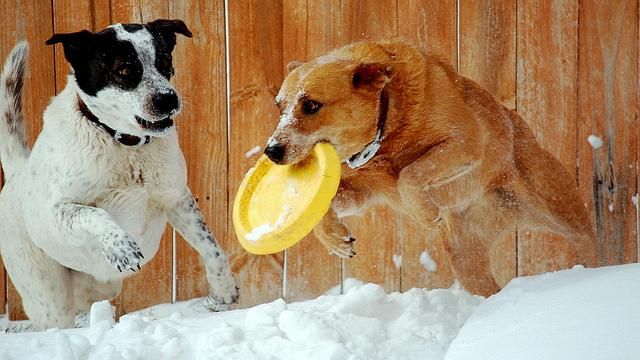What game are they playing? Please explain your reasoning. fetch. The speed shown in the orange dog expresses a need to get the toy back to its owner asap. this is usually done when said human has just thrown the toy for the dog to retrieve. 